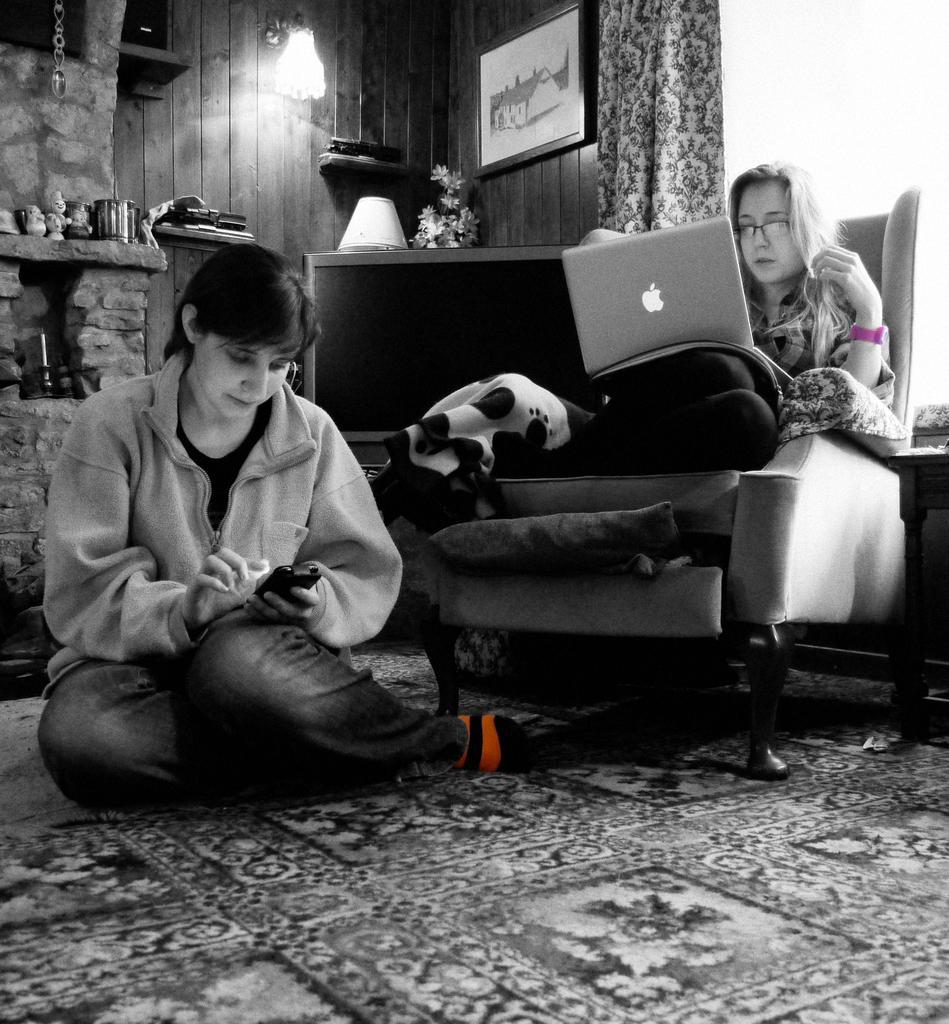How would you summarize this image in a sentence or two? Black and white picture. This woman is sitting on floor and this woman is sitting on a couch and working on laptop. A picture and light on wall. This is window with curtain. Backside of this television there is a lamp and plant. 